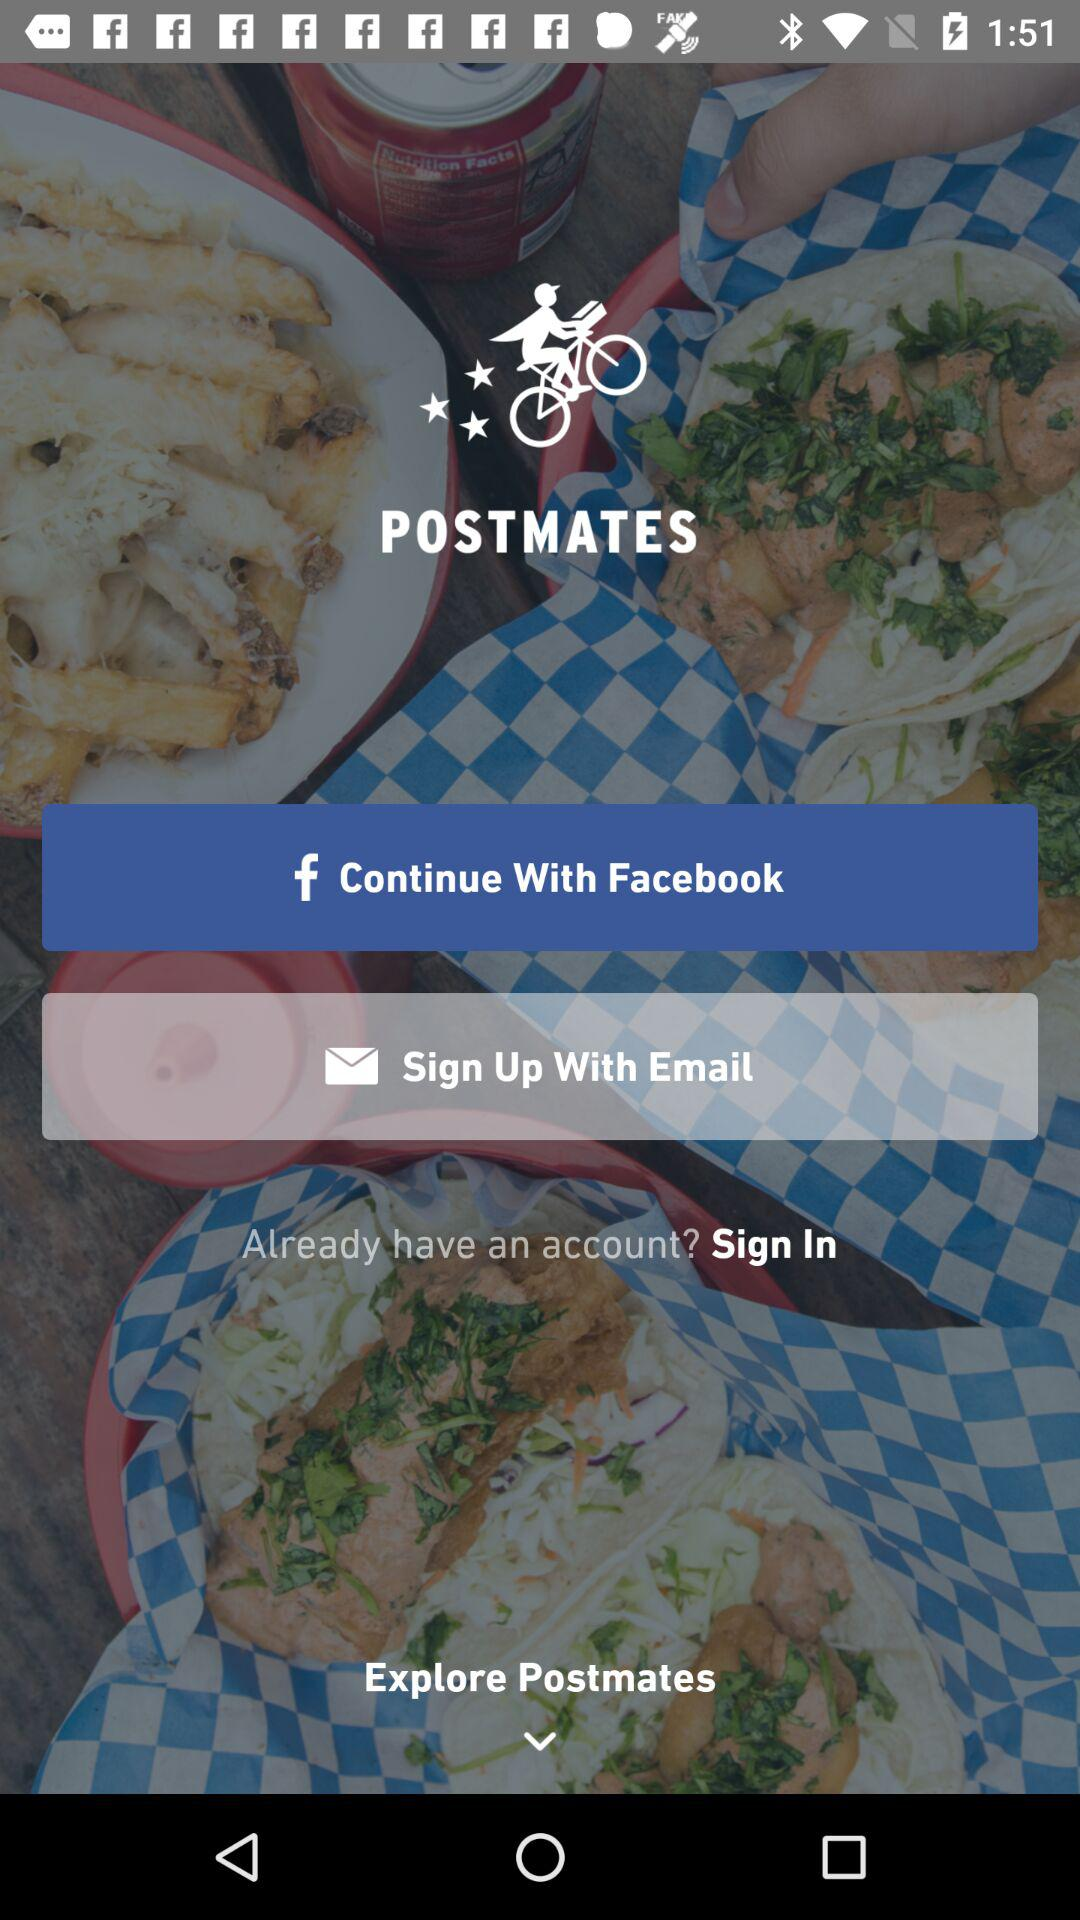What's the name of the account by which the application can continue to perform? The name of the account by which the application can continue to perform is "Facebook". 